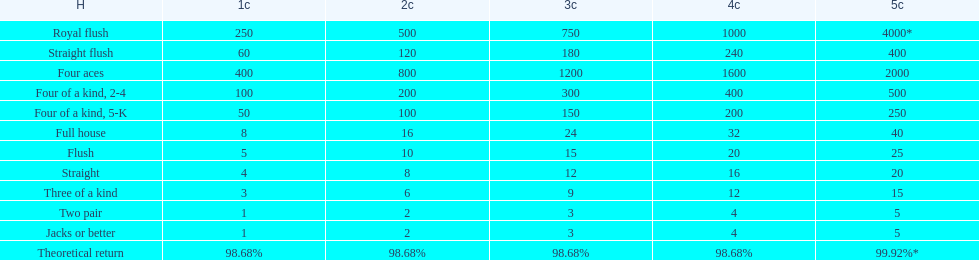Help me parse the entirety of this table. {'header': ['H', '1c', '2c', '3c', '4c', '5c'], 'rows': [['Royal flush', '250', '500', '750', '1000', '4000*'], ['Straight flush', '60', '120', '180', '240', '400'], ['Four aces', '400', '800', '1200', '1600', '2000'], ['Four of a kind, 2-4', '100', '200', '300', '400', '500'], ['Four of a kind, 5-K', '50', '100', '150', '200', '250'], ['Full house', '8', '16', '24', '32', '40'], ['Flush', '5', '10', '15', '20', '25'], ['Straight', '4', '8', '12', '16', '20'], ['Three of a kind', '3', '6', '9', '12', '15'], ['Two pair', '1', '2', '3', '4', '5'], ['Jacks or better', '1', '2', '3', '4', '5'], ['Theoretical return', '98.68%', '98.68%', '98.68%', '98.68%', '99.92%*']]} How many straight wins at 3 credits equals one straight flush win at two credits? 10. 